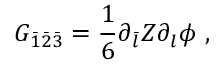<formula> <loc_0><loc_0><loc_500><loc_500>G _ { \bar { 1 } \bar { 2 } \bar { 3 } } = \frac { 1 } { 6 } \partial _ { \bar { l } } Z \partial _ { l } \phi \ ,</formula> 